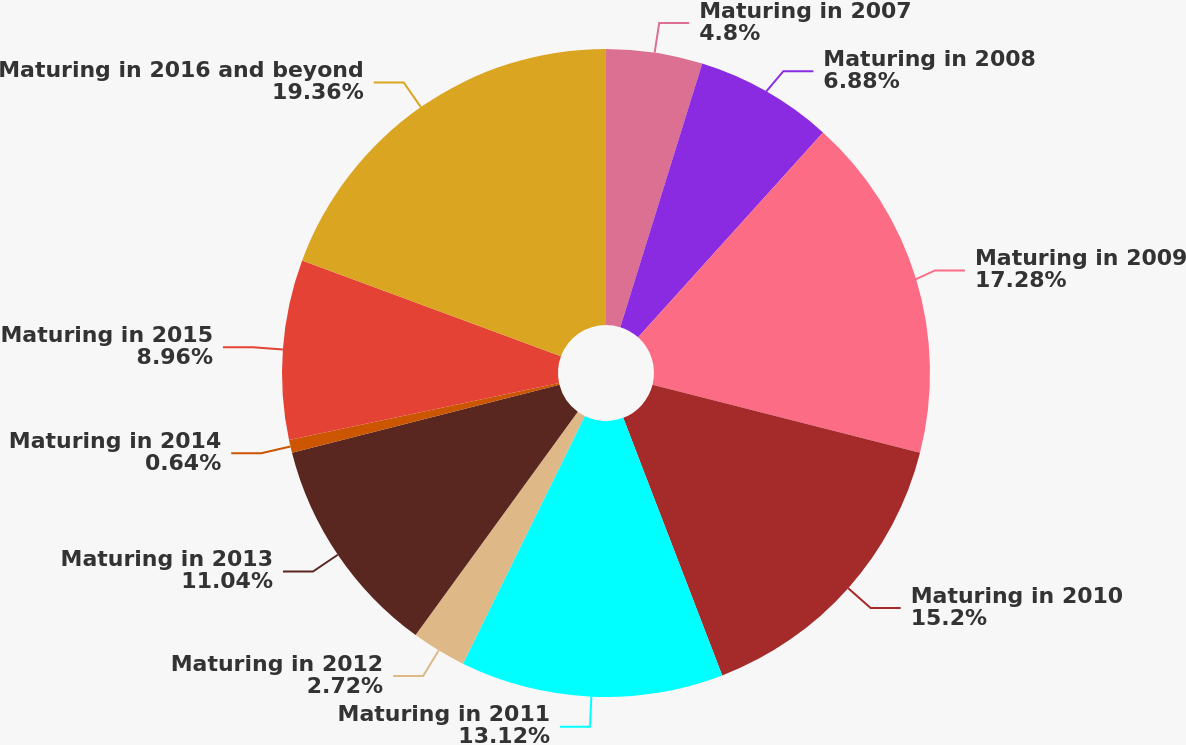Convert chart to OTSL. <chart><loc_0><loc_0><loc_500><loc_500><pie_chart><fcel>Maturing in 2007<fcel>Maturing in 2008<fcel>Maturing in 2009<fcel>Maturing in 2010<fcel>Maturing in 2011<fcel>Maturing in 2012<fcel>Maturing in 2013<fcel>Maturing in 2014<fcel>Maturing in 2015<fcel>Maturing in 2016 and beyond<nl><fcel>4.8%<fcel>6.88%<fcel>17.28%<fcel>15.2%<fcel>13.12%<fcel>2.72%<fcel>11.04%<fcel>0.64%<fcel>8.96%<fcel>19.36%<nl></chart> 